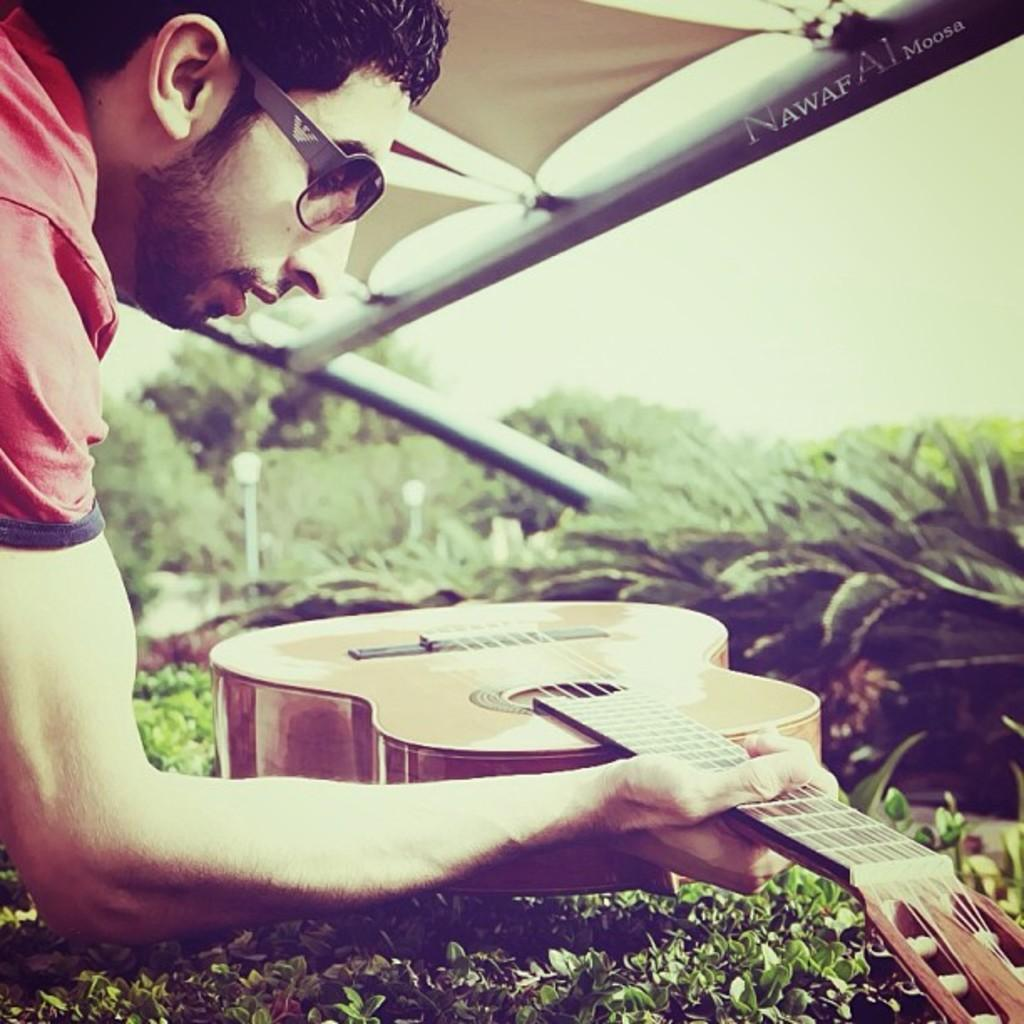Who is present in the image? There is a man in the image. What is the man holding in the image? The man is holding a guitar. What else can be seen in the image besides the man and the guitar? There are plants in the image. What is the man's theory about the end of the universe in the image? There is no information about the man's theory about the end of the universe in the image. 